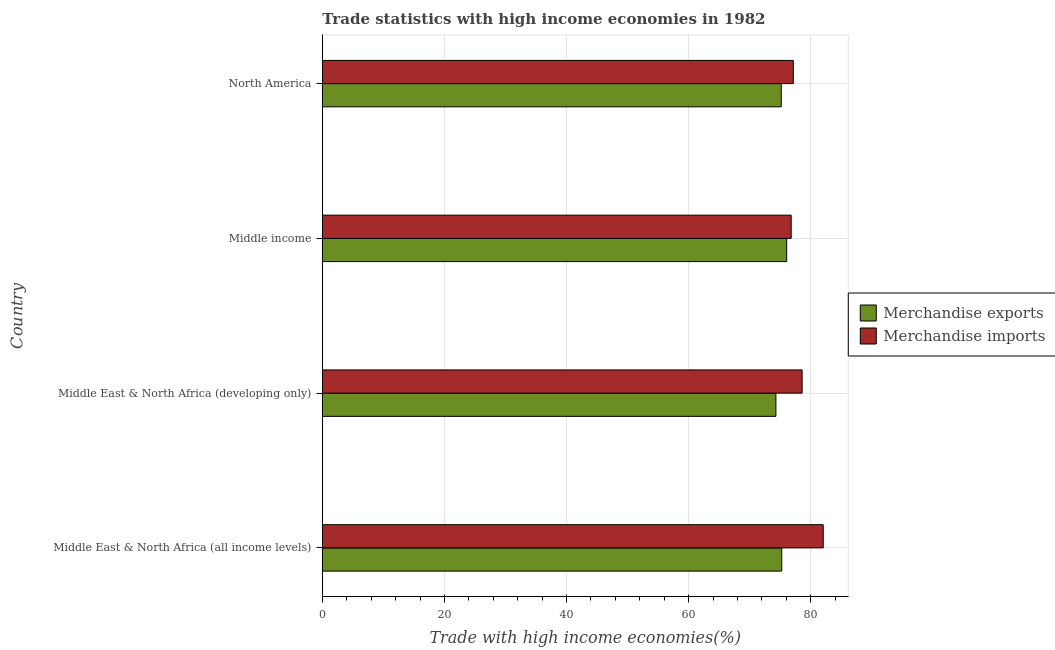How many groups of bars are there?
Your answer should be compact. 4. Are the number of bars per tick equal to the number of legend labels?
Keep it short and to the point. Yes. Are the number of bars on each tick of the Y-axis equal?
Your answer should be compact. Yes. What is the label of the 1st group of bars from the top?
Offer a terse response. North America. In how many cases, is the number of bars for a given country not equal to the number of legend labels?
Ensure brevity in your answer.  0. What is the merchandise imports in Middle East & North Africa (developing only)?
Provide a short and direct response. 78.59. Across all countries, what is the maximum merchandise exports?
Your answer should be very brief. 76.06. Across all countries, what is the minimum merchandise imports?
Your answer should be very brief. 76.79. In which country was the merchandise imports maximum?
Offer a very short reply. Middle East & North Africa (all income levels). In which country was the merchandise imports minimum?
Offer a very short reply. Middle income. What is the total merchandise exports in the graph?
Make the answer very short. 300.76. What is the difference between the merchandise imports in Middle East & North Africa (all income levels) and that in Middle East & North Africa (developing only)?
Your answer should be compact. 3.46. What is the difference between the merchandise imports in North America and the merchandise exports in Middle East & North Africa (developing only)?
Give a very brief answer. 2.85. What is the average merchandise imports per country?
Give a very brief answer. 78.64. What is the difference between the merchandise exports and merchandise imports in North America?
Keep it short and to the point. -1.97. What is the difference between the highest and the second highest merchandise imports?
Offer a terse response. 3.46. What is the difference between the highest and the lowest merchandise imports?
Give a very brief answer. 5.25. In how many countries, is the merchandise imports greater than the average merchandise imports taken over all countries?
Offer a very short reply. 1. What does the 2nd bar from the top in Middle income represents?
Make the answer very short. Merchandise exports. Are the values on the major ticks of X-axis written in scientific E-notation?
Your answer should be compact. No. Does the graph contain any zero values?
Provide a succinct answer. No. Does the graph contain grids?
Provide a succinct answer. Yes. Where does the legend appear in the graph?
Keep it short and to the point. Center right. What is the title of the graph?
Offer a very short reply. Trade statistics with high income economies in 1982. Does "Electricity and heat production" appear as one of the legend labels in the graph?
Offer a terse response. No. What is the label or title of the X-axis?
Make the answer very short. Trade with high income economies(%). What is the Trade with high income economies(%) of Merchandise exports in Middle East & North Africa (all income levels)?
Provide a succinct answer. 75.25. What is the Trade with high income economies(%) of Merchandise imports in Middle East & North Africa (all income levels)?
Ensure brevity in your answer.  82.04. What is the Trade with high income economies(%) in Merchandise exports in Middle East & North Africa (developing only)?
Give a very brief answer. 74.29. What is the Trade with high income economies(%) in Merchandise imports in Middle East & North Africa (developing only)?
Your response must be concise. 78.59. What is the Trade with high income economies(%) in Merchandise exports in Middle income?
Provide a succinct answer. 76.06. What is the Trade with high income economies(%) of Merchandise imports in Middle income?
Offer a terse response. 76.79. What is the Trade with high income economies(%) of Merchandise exports in North America?
Offer a terse response. 75.17. What is the Trade with high income economies(%) of Merchandise imports in North America?
Make the answer very short. 77.14. Across all countries, what is the maximum Trade with high income economies(%) of Merchandise exports?
Ensure brevity in your answer.  76.06. Across all countries, what is the maximum Trade with high income economies(%) of Merchandise imports?
Your answer should be compact. 82.04. Across all countries, what is the minimum Trade with high income economies(%) of Merchandise exports?
Offer a terse response. 74.29. Across all countries, what is the minimum Trade with high income economies(%) of Merchandise imports?
Your answer should be compact. 76.79. What is the total Trade with high income economies(%) of Merchandise exports in the graph?
Provide a succinct answer. 300.76. What is the total Trade with high income economies(%) in Merchandise imports in the graph?
Keep it short and to the point. 314.56. What is the difference between the Trade with high income economies(%) of Merchandise exports in Middle East & North Africa (all income levels) and that in Middle East & North Africa (developing only)?
Provide a short and direct response. 0.96. What is the difference between the Trade with high income economies(%) of Merchandise imports in Middle East & North Africa (all income levels) and that in Middle East & North Africa (developing only)?
Ensure brevity in your answer.  3.46. What is the difference between the Trade with high income economies(%) of Merchandise exports in Middle East & North Africa (all income levels) and that in Middle income?
Your answer should be compact. -0.81. What is the difference between the Trade with high income economies(%) of Merchandise imports in Middle East & North Africa (all income levels) and that in Middle income?
Offer a very short reply. 5.25. What is the difference between the Trade with high income economies(%) of Merchandise exports in Middle East & North Africa (all income levels) and that in North America?
Provide a succinct answer. 0.08. What is the difference between the Trade with high income economies(%) in Merchandise imports in Middle East & North Africa (all income levels) and that in North America?
Make the answer very short. 4.9. What is the difference between the Trade with high income economies(%) of Merchandise exports in Middle East & North Africa (developing only) and that in Middle income?
Make the answer very short. -1.77. What is the difference between the Trade with high income economies(%) in Merchandise imports in Middle East & North Africa (developing only) and that in Middle income?
Your answer should be compact. 1.79. What is the difference between the Trade with high income economies(%) of Merchandise exports in Middle East & North Africa (developing only) and that in North America?
Provide a succinct answer. -0.88. What is the difference between the Trade with high income economies(%) in Merchandise imports in Middle East & North Africa (developing only) and that in North America?
Give a very brief answer. 1.45. What is the difference between the Trade with high income economies(%) of Merchandise exports in Middle income and that in North America?
Keep it short and to the point. 0.89. What is the difference between the Trade with high income economies(%) of Merchandise imports in Middle income and that in North America?
Your answer should be compact. -0.34. What is the difference between the Trade with high income economies(%) of Merchandise exports in Middle East & North Africa (all income levels) and the Trade with high income economies(%) of Merchandise imports in Middle East & North Africa (developing only)?
Provide a succinct answer. -3.34. What is the difference between the Trade with high income economies(%) of Merchandise exports in Middle East & North Africa (all income levels) and the Trade with high income economies(%) of Merchandise imports in Middle income?
Keep it short and to the point. -1.55. What is the difference between the Trade with high income economies(%) of Merchandise exports in Middle East & North Africa (all income levels) and the Trade with high income economies(%) of Merchandise imports in North America?
Your response must be concise. -1.89. What is the difference between the Trade with high income economies(%) in Merchandise exports in Middle East & North Africa (developing only) and the Trade with high income economies(%) in Merchandise imports in Middle income?
Make the answer very short. -2.5. What is the difference between the Trade with high income economies(%) of Merchandise exports in Middle East & North Africa (developing only) and the Trade with high income economies(%) of Merchandise imports in North America?
Ensure brevity in your answer.  -2.85. What is the difference between the Trade with high income economies(%) in Merchandise exports in Middle income and the Trade with high income economies(%) in Merchandise imports in North America?
Keep it short and to the point. -1.08. What is the average Trade with high income economies(%) in Merchandise exports per country?
Your response must be concise. 75.19. What is the average Trade with high income economies(%) of Merchandise imports per country?
Offer a terse response. 78.64. What is the difference between the Trade with high income economies(%) of Merchandise exports and Trade with high income economies(%) of Merchandise imports in Middle East & North Africa (all income levels)?
Your answer should be very brief. -6.8. What is the difference between the Trade with high income economies(%) of Merchandise exports and Trade with high income economies(%) of Merchandise imports in Middle East & North Africa (developing only)?
Provide a succinct answer. -4.3. What is the difference between the Trade with high income economies(%) of Merchandise exports and Trade with high income economies(%) of Merchandise imports in Middle income?
Your answer should be very brief. -0.73. What is the difference between the Trade with high income economies(%) in Merchandise exports and Trade with high income economies(%) in Merchandise imports in North America?
Provide a succinct answer. -1.97. What is the ratio of the Trade with high income economies(%) of Merchandise exports in Middle East & North Africa (all income levels) to that in Middle East & North Africa (developing only)?
Your answer should be compact. 1.01. What is the ratio of the Trade with high income economies(%) of Merchandise imports in Middle East & North Africa (all income levels) to that in Middle East & North Africa (developing only)?
Provide a succinct answer. 1.04. What is the ratio of the Trade with high income economies(%) in Merchandise exports in Middle East & North Africa (all income levels) to that in Middle income?
Offer a very short reply. 0.99. What is the ratio of the Trade with high income economies(%) of Merchandise imports in Middle East & North Africa (all income levels) to that in Middle income?
Your answer should be very brief. 1.07. What is the ratio of the Trade with high income economies(%) in Merchandise exports in Middle East & North Africa (all income levels) to that in North America?
Offer a very short reply. 1. What is the ratio of the Trade with high income economies(%) in Merchandise imports in Middle East & North Africa (all income levels) to that in North America?
Make the answer very short. 1.06. What is the ratio of the Trade with high income economies(%) of Merchandise exports in Middle East & North Africa (developing only) to that in Middle income?
Your answer should be very brief. 0.98. What is the ratio of the Trade with high income economies(%) in Merchandise imports in Middle East & North Africa (developing only) to that in Middle income?
Provide a short and direct response. 1.02. What is the ratio of the Trade with high income economies(%) in Merchandise exports in Middle East & North Africa (developing only) to that in North America?
Offer a very short reply. 0.99. What is the ratio of the Trade with high income economies(%) in Merchandise imports in Middle East & North Africa (developing only) to that in North America?
Keep it short and to the point. 1.02. What is the ratio of the Trade with high income economies(%) of Merchandise exports in Middle income to that in North America?
Make the answer very short. 1.01. What is the difference between the highest and the second highest Trade with high income economies(%) in Merchandise exports?
Make the answer very short. 0.81. What is the difference between the highest and the second highest Trade with high income economies(%) in Merchandise imports?
Ensure brevity in your answer.  3.46. What is the difference between the highest and the lowest Trade with high income economies(%) in Merchandise exports?
Provide a succinct answer. 1.77. What is the difference between the highest and the lowest Trade with high income economies(%) of Merchandise imports?
Offer a terse response. 5.25. 